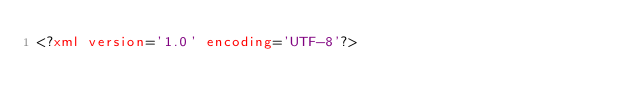<code> <loc_0><loc_0><loc_500><loc_500><_XML_><?xml version='1.0' encoding='UTF-8'?></code> 